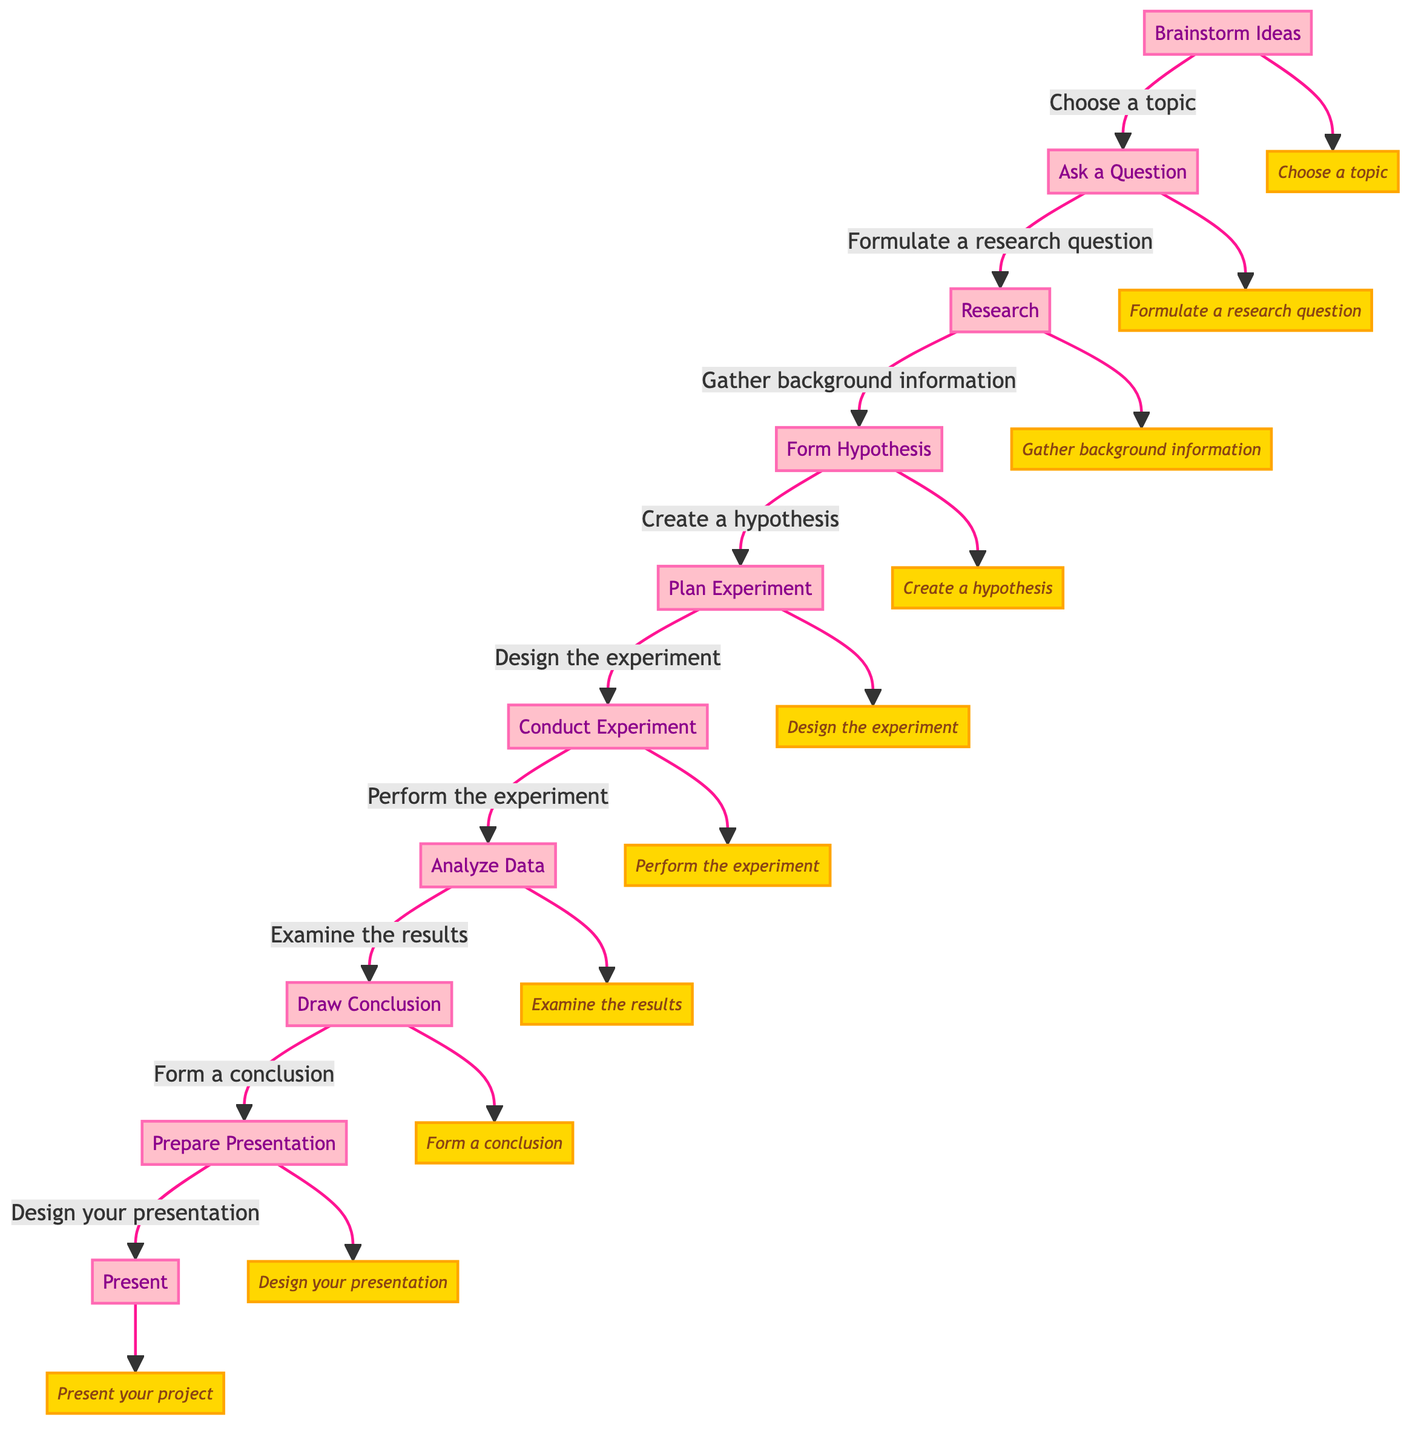What is the first step in the project? The diagram lists "Brainstorm Ideas" as the first step in organizing a science fair project. It indicates that this is where one should think about interesting science topics.
Answer: Brainstorm Ideas How many steps are there in total? The diagram shows a sequence of ten distinct steps in the process of organizing a science fair project, from brainstorming ideas to presenting the project.
Answer: 10 What action follows "Conduct Experiment"? The diagram indicates that the step that comes after "Conduct Experiment" is "Analyze Data," which involves examining the results obtained from the experiment.
Answer: Analyze Data Which step directly leads to preparing for the presentation? From the diagram, "Draw Conclusion" leads directly to "Prepare Presentation." This means after concluding the experiment, one should prepare to present findings.
Answer: Draw Conclusion What is the action associated with drawing a conclusion? The action linked to "Draw Conclusion" in the diagram is to form a conclusion, which involves interpreting the results of the experiment to determine if the hypothesis was supported.
Answer: Form a conclusion How does "Research" connect to "Ask a Question"? In the diagram, "Research" follows "Ask a Question," indicating that after formulating a research question, the next step involves gathering information related to that question.
Answer: Research What step involves creating a hypothesis? The step dedicated to creating a hypothesis is "Form Hypothesis," which follows the research stage in the diagram, where one makes a guess about the expected outcome of the experiment.
Answer: Form Hypothesis Which step is before "Prepare Presentation"? Before "Prepare Presentation," the diagram shows "Draw Conclusion" as the immediate preceding step, indicating that a conclusion must be made prior to preparing the project presentation.
Answer: Draw Conclusion What is the last task in the sequence? The final task in the sequence presented in the diagram is "Present," which involves sharing the project findings at the science fair.
Answer: Present 